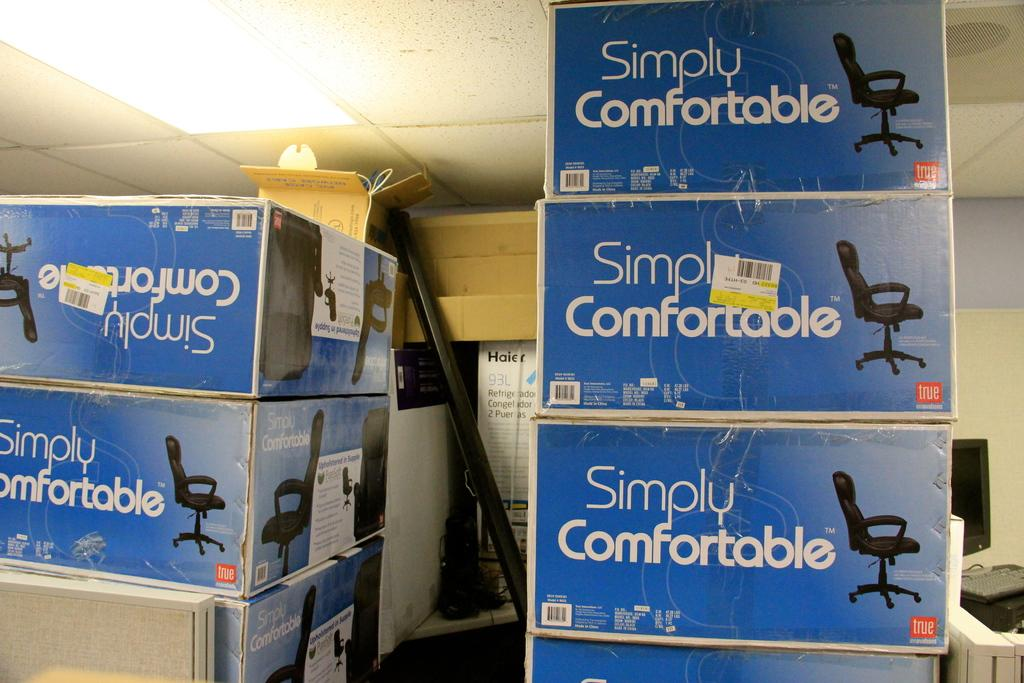<image>
Create a compact narrative representing the image presented. Simply Comfortable is the brand printed on the side of these boxes. 